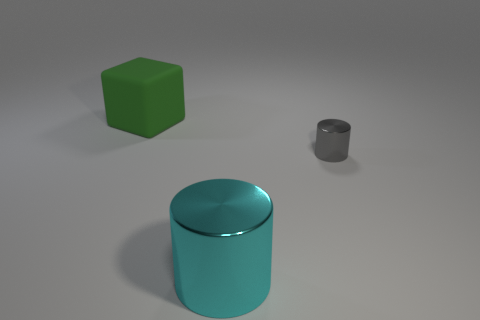Add 2 red rubber things. How many objects exist? 5 Subtract all gray cylinders. How many cylinders are left? 1 Subtract 1 cylinders. How many cylinders are left? 1 Subtract all blocks. How many objects are left? 2 Add 1 large green matte objects. How many large green matte objects are left? 2 Add 2 purple shiny spheres. How many purple shiny spheres exist? 2 Subtract 0 green spheres. How many objects are left? 3 Subtract all red blocks. Subtract all green balls. How many blocks are left? 1 Subtract all red balls. How many cyan cubes are left? 0 Subtract all small objects. Subtract all big red cylinders. How many objects are left? 2 